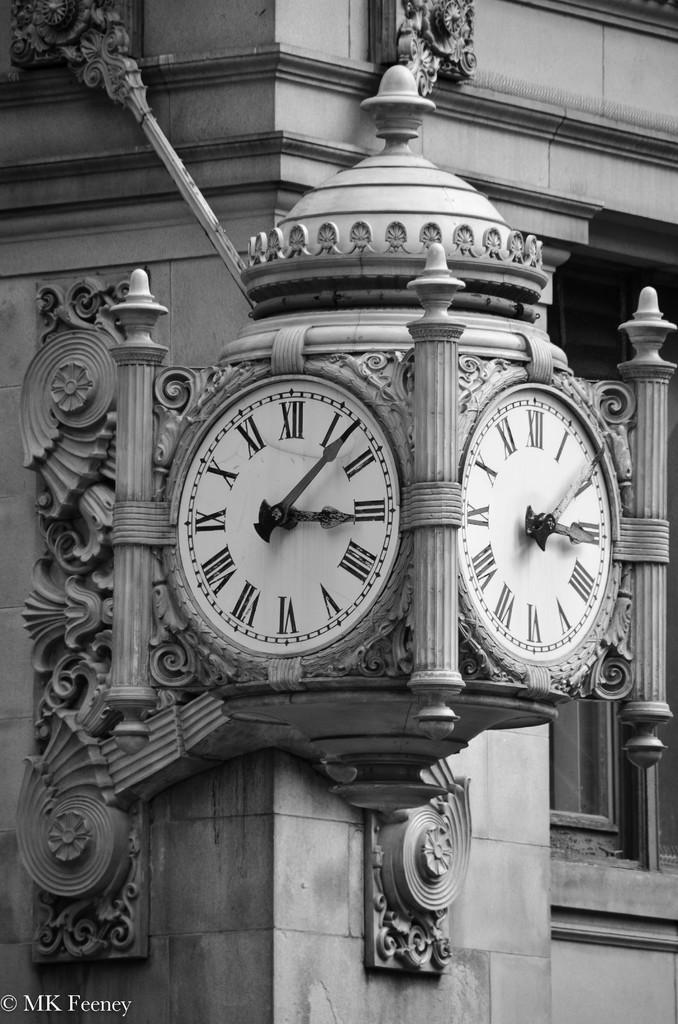<image>
Render a clear and concise summary of the photo. A picture of a tower clock that was taken by MK Feeney. 